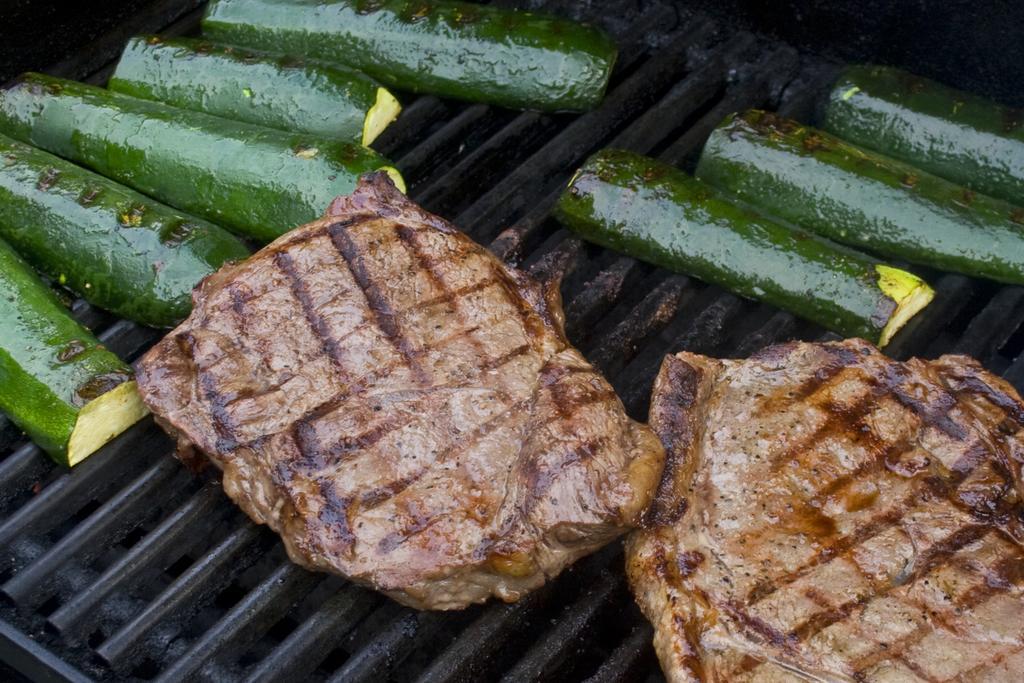In one or two sentences, can you explain what this image depicts? In this image there is grille truncated, there is food on the grille, the food is truncated. 